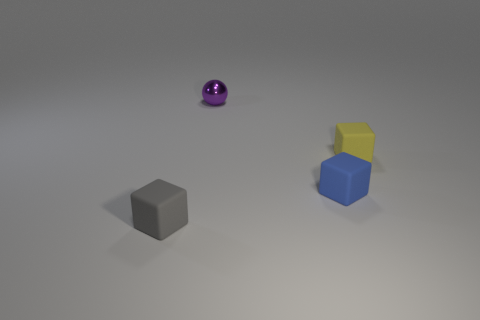What materials do the objects in the image appear to be made of? The tiny purple ball has a metallic sheen, indicating it is likely made of metal. The brown object has a matte finish, suggestive of either wood or plastic, while the blue and yellow cubes appear to have a plastic look with their vibrant colors and light reflection. 